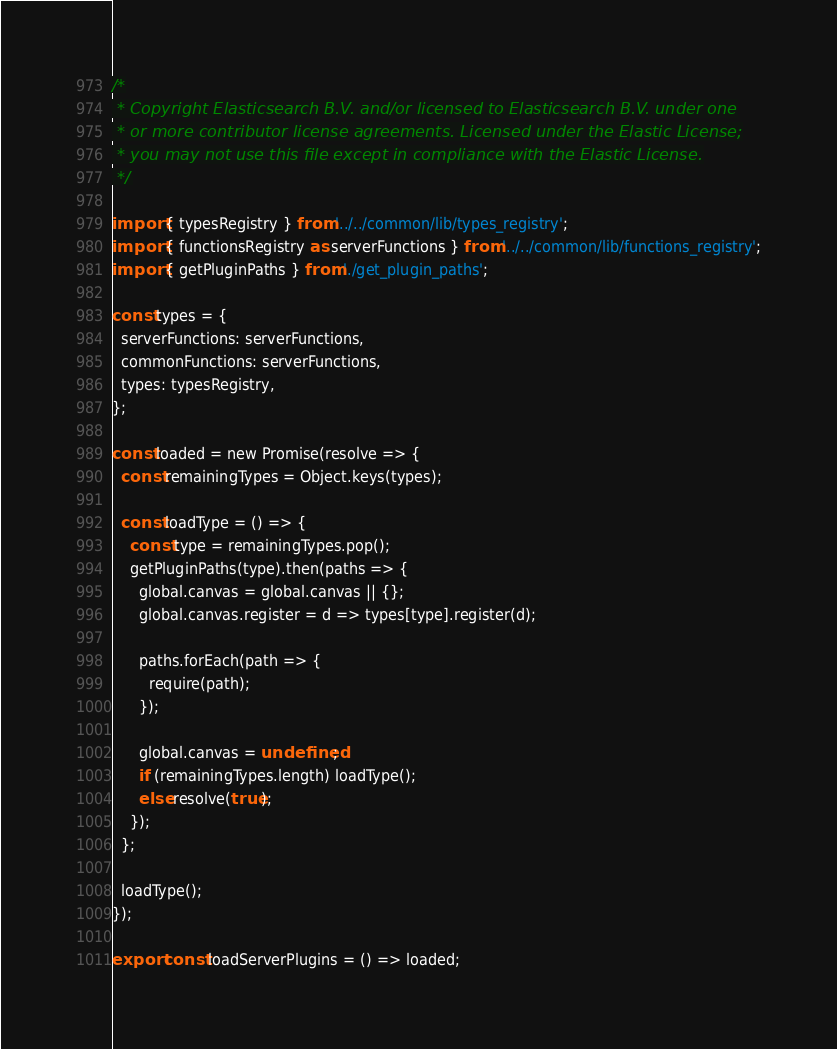Convert code to text. <code><loc_0><loc_0><loc_500><loc_500><_JavaScript_>/*
 * Copyright Elasticsearch B.V. and/or licensed to Elasticsearch B.V. under one
 * or more contributor license agreements. Licensed under the Elastic License;
 * you may not use this file except in compliance with the Elastic License.
 */

import { typesRegistry } from '../../common/lib/types_registry';
import { functionsRegistry as serverFunctions } from '../../common/lib/functions_registry';
import { getPluginPaths } from './get_plugin_paths';

const types = {
  serverFunctions: serverFunctions,
  commonFunctions: serverFunctions,
  types: typesRegistry,
};

const loaded = new Promise(resolve => {
  const remainingTypes = Object.keys(types);

  const loadType = () => {
    const type = remainingTypes.pop();
    getPluginPaths(type).then(paths => {
      global.canvas = global.canvas || {};
      global.canvas.register = d => types[type].register(d);

      paths.forEach(path => {
        require(path);
      });

      global.canvas = undefined;
      if (remainingTypes.length) loadType();
      else resolve(true);
    });
  };

  loadType();
});

export const loadServerPlugins = () => loaded;
</code> 